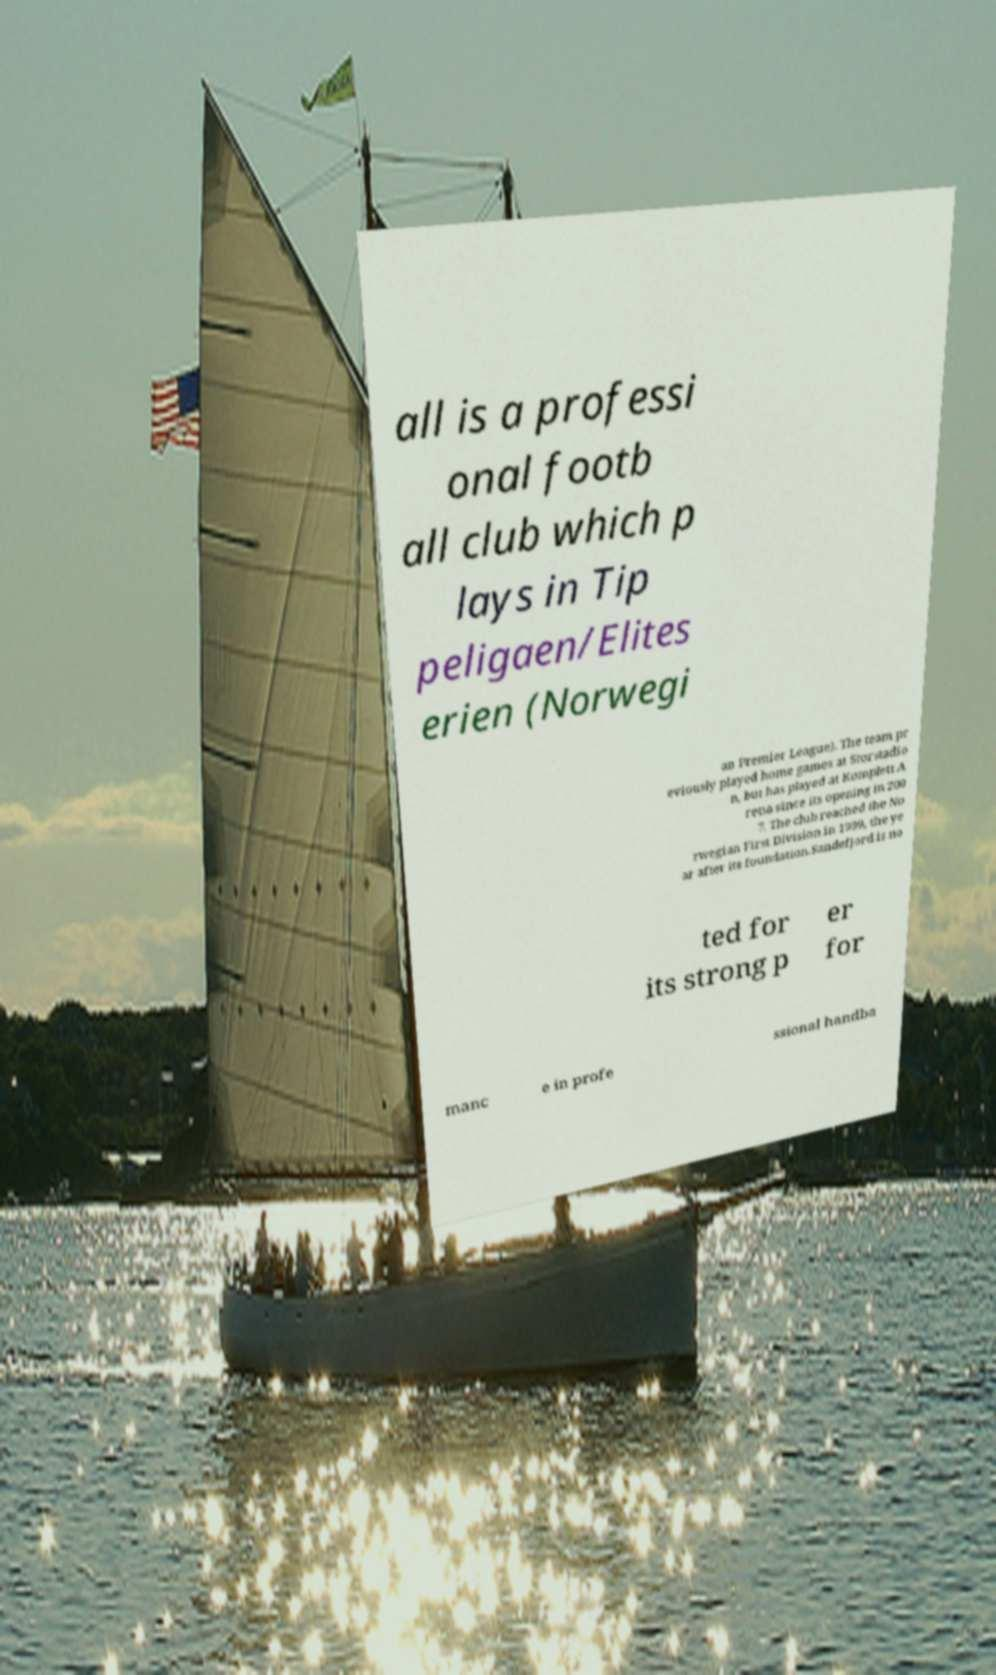What messages or text are displayed in this image? I need them in a readable, typed format. all is a professi onal footb all club which p lays in Tip peligaen/Elites erien (Norwegi an Premier League). The team pr eviously played home games at Storstadio n, but has played at Komplett A rena since its opening in 200 7. The club reached the No rwegian First Division in 1999, the ye ar after its foundation.Sandefjord is no ted for its strong p er for manc e in profe ssional handba 